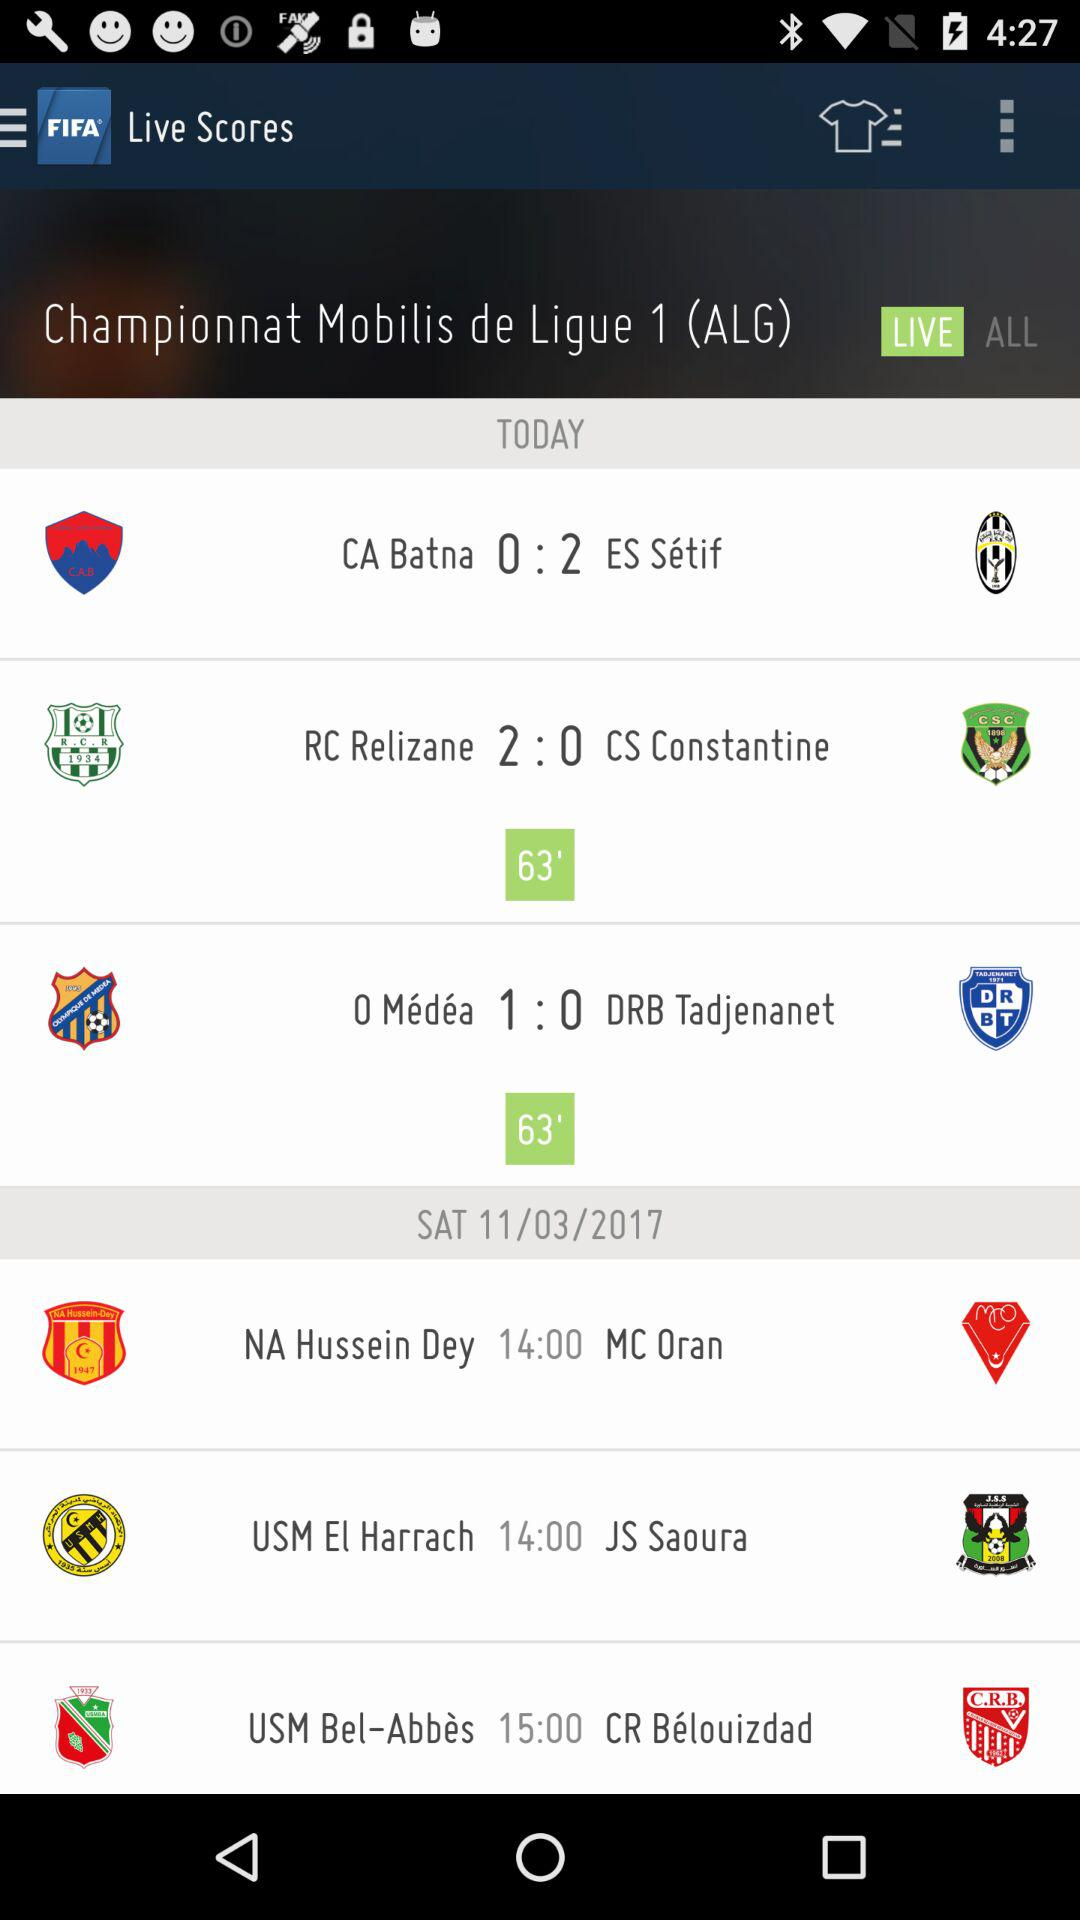What is the time of the first match of NA vs MC? The time of the first match of NA vs MC is 14:00. 